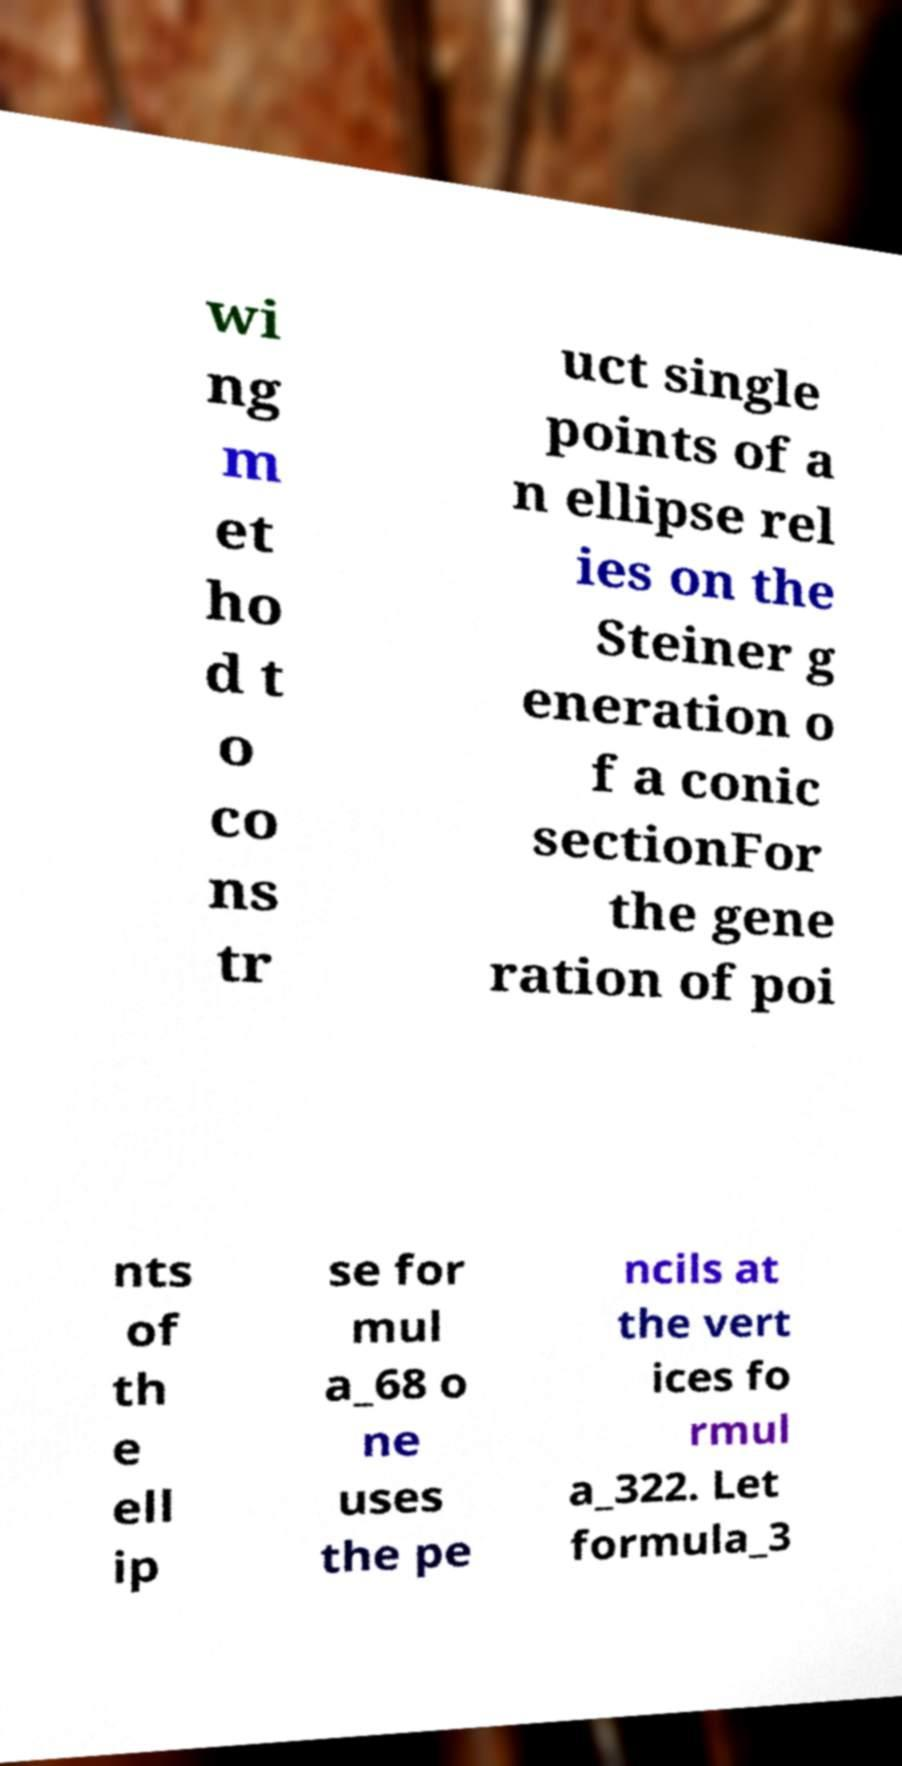Can you accurately transcribe the text from the provided image for me? wi ng m et ho d t o co ns tr uct single points of a n ellipse rel ies on the Steiner g eneration o f a conic sectionFor the gene ration of poi nts of th e ell ip se for mul a_68 o ne uses the pe ncils at the vert ices fo rmul a_322. Let formula_3 